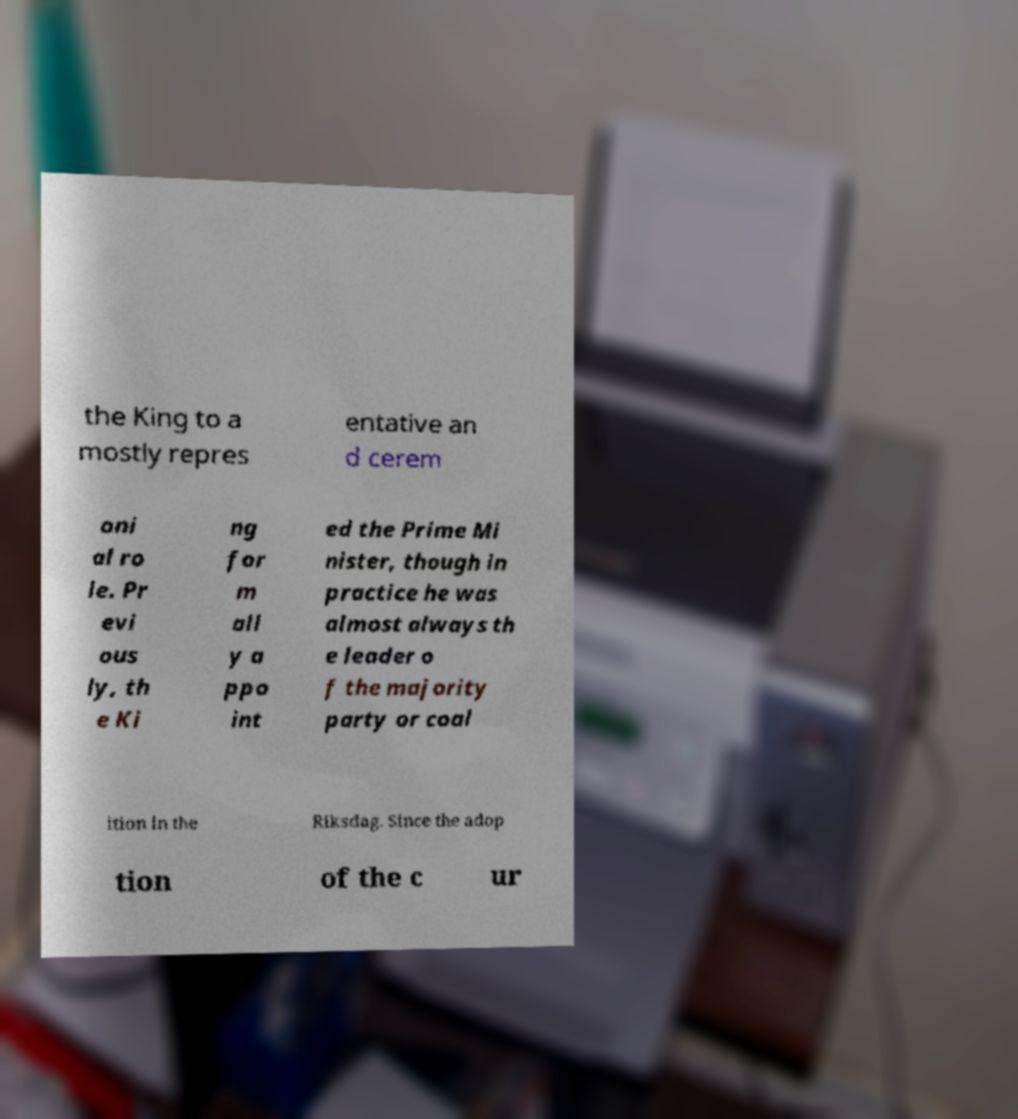For documentation purposes, I need the text within this image transcribed. Could you provide that? the King to a mostly repres entative an d cerem oni al ro le. Pr evi ous ly, th e Ki ng for m all y a ppo int ed the Prime Mi nister, though in practice he was almost always th e leader o f the majority party or coal ition in the Riksdag. Since the adop tion of the c ur 